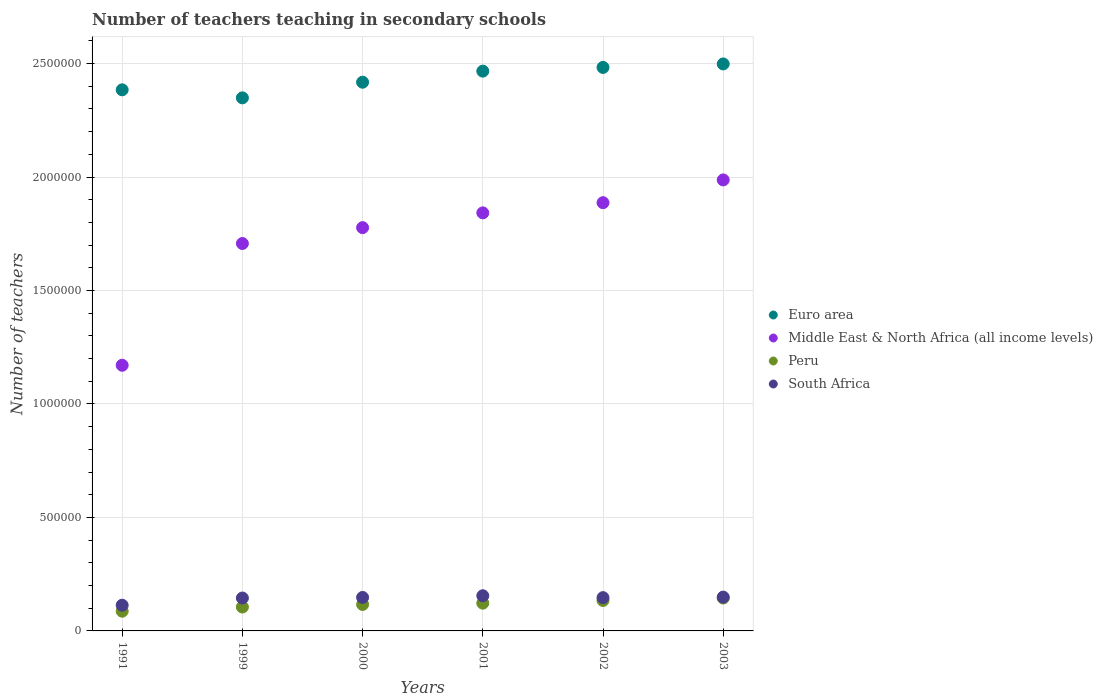How many different coloured dotlines are there?
Offer a terse response. 4. Is the number of dotlines equal to the number of legend labels?
Offer a terse response. Yes. What is the number of teachers teaching in secondary schools in Euro area in 1991?
Offer a very short reply. 2.38e+06. Across all years, what is the maximum number of teachers teaching in secondary schools in Middle East & North Africa (all income levels)?
Ensure brevity in your answer.  1.99e+06. Across all years, what is the minimum number of teachers teaching in secondary schools in South Africa?
Make the answer very short. 1.13e+05. In which year was the number of teachers teaching in secondary schools in Peru minimum?
Your response must be concise. 1991. What is the total number of teachers teaching in secondary schools in South Africa in the graph?
Your response must be concise. 8.56e+05. What is the difference between the number of teachers teaching in secondary schools in Euro area in 2000 and that in 2001?
Provide a short and direct response. -4.88e+04. What is the difference between the number of teachers teaching in secondary schools in Middle East & North Africa (all income levels) in 1991 and the number of teachers teaching in secondary schools in South Africa in 2003?
Provide a succinct answer. 1.02e+06. What is the average number of teachers teaching in secondary schools in Middle East & North Africa (all income levels) per year?
Your answer should be compact. 1.73e+06. In the year 1991, what is the difference between the number of teachers teaching in secondary schools in Middle East & North Africa (all income levels) and number of teachers teaching in secondary schools in Euro area?
Make the answer very short. -1.21e+06. What is the ratio of the number of teachers teaching in secondary schools in South Africa in 1999 to that in 2002?
Provide a short and direct response. 0.99. What is the difference between the highest and the second highest number of teachers teaching in secondary schools in Peru?
Your response must be concise. 1.08e+04. What is the difference between the highest and the lowest number of teachers teaching in secondary schools in Euro area?
Your response must be concise. 1.49e+05. Is the sum of the number of teachers teaching in secondary schools in Peru in 1991 and 1999 greater than the maximum number of teachers teaching in secondary schools in Euro area across all years?
Provide a short and direct response. No. Is the number of teachers teaching in secondary schools in Middle East & North Africa (all income levels) strictly greater than the number of teachers teaching in secondary schools in Peru over the years?
Your response must be concise. Yes. Is the number of teachers teaching in secondary schools in South Africa strictly less than the number of teachers teaching in secondary schools in Euro area over the years?
Provide a short and direct response. Yes. How many dotlines are there?
Give a very brief answer. 4. What is the difference between two consecutive major ticks on the Y-axis?
Your answer should be very brief. 5.00e+05. How many legend labels are there?
Give a very brief answer. 4. How are the legend labels stacked?
Keep it short and to the point. Vertical. What is the title of the graph?
Offer a terse response. Number of teachers teaching in secondary schools. What is the label or title of the Y-axis?
Your answer should be very brief. Number of teachers. What is the Number of teachers in Euro area in 1991?
Provide a short and direct response. 2.38e+06. What is the Number of teachers in Middle East & North Africa (all income levels) in 1991?
Keep it short and to the point. 1.17e+06. What is the Number of teachers in Peru in 1991?
Your answer should be very brief. 8.69e+04. What is the Number of teachers of South Africa in 1991?
Give a very brief answer. 1.13e+05. What is the Number of teachers in Euro area in 1999?
Your answer should be very brief. 2.35e+06. What is the Number of teachers in Middle East & North Africa (all income levels) in 1999?
Give a very brief answer. 1.71e+06. What is the Number of teachers in Peru in 1999?
Provide a succinct answer. 1.05e+05. What is the Number of teachers in South Africa in 1999?
Your response must be concise. 1.45e+05. What is the Number of teachers of Euro area in 2000?
Give a very brief answer. 2.42e+06. What is the Number of teachers of Middle East & North Africa (all income levels) in 2000?
Provide a short and direct response. 1.78e+06. What is the Number of teachers in Peru in 2000?
Make the answer very short. 1.17e+05. What is the Number of teachers in South Africa in 2000?
Your response must be concise. 1.48e+05. What is the Number of teachers of Euro area in 2001?
Make the answer very short. 2.47e+06. What is the Number of teachers of Middle East & North Africa (all income levels) in 2001?
Keep it short and to the point. 1.84e+06. What is the Number of teachers in Peru in 2001?
Give a very brief answer. 1.22e+05. What is the Number of teachers in South Africa in 2001?
Give a very brief answer. 1.55e+05. What is the Number of teachers in Euro area in 2002?
Provide a succinct answer. 2.48e+06. What is the Number of teachers of Middle East & North Africa (all income levels) in 2002?
Make the answer very short. 1.89e+06. What is the Number of teachers in Peru in 2002?
Your response must be concise. 1.34e+05. What is the Number of teachers of South Africa in 2002?
Offer a terse response. 1.47e+05. What is the Number of teachers in Euro area in 2003?
Offer a very short reply. 2.50e+06. What is the Number of teachers in Middle East & North Africa (all income levels) in 2003?
Offer a terse response. 1.99e+06. What is the Number of teachers in Peru in 2003?
Offer a very short reply. 1.45e+05. What is the Number of teachers in South Africa in 2003?
Offer a terse response. 1.49e+05. Across all years, what is the maximum Number of teachers of Euro area?
Provide a short and direct response. 2.50e+06. Across all years, what is the maximum Number of teachers of Middle East & North Africa (all income levels)?
Give a very brief answer. 1.99e+06. Across all years, what is the maximum Number of teachers in Peru?
Your answer should be compact. 1.45e+05. Across all years, what is the maximum Number of teachers in South Africa?
Ensure brevity in your answer.  1.55e+05. Across all years, what is the minimum Number of teachers of Euro area?
Your response must be concise. 2.35e+06. Across all years, what is the minimum Number of teachers of Middle East & North Africa (all income levels)?
Provide a succinct answer. 1.17e+06. Across all years, what is the minimum Number of teachers of Peru?
Your answer should be compact. 8.69e+04. Across all years, what is the minimum Number of teachers in South Africa?
Your answer should be compact. 1.13e+05. What is the total Number of teachers of Euro area in the graph?
Your answer should be compact. 1.46e+07. What is the total Number of teachers in Middle East & North Africa (all income levels) in the graph?
Provide a succinct answer. 1.04e+07. What is the total Number of teachers in Peru in the graph?
Your response must be concise. 7.10e+05. What is the total Number of teachers in South Africa in the graph?
Ensure brevity in your answer.  8.56e+05. What is the difference between the Number of teachers in Euro area in 1991 and that in 1999?
Provide a succinct answer. 3.54e+04. What is the difference between the Number of teachers of Middle East & North Africa (all income levels) in 1991 and that in 1999?
Your answer should be very brief. -5.36e+05. What is the difference between the Number of teachers of Peru in 1991 and that in 1999?
Your answer should be compact. -1.84e+04. What is the difference between the Number of teachers in South Africa in 1991 and that in 1999?
Your answer should be very brief. -3.17e+04. What is the difference between the Number of teachers of Euro area in 1991 and that in 2000?
Your answer should be compact. -3.36e+04. What is the difference between the Number of teachers in Middle East & North Africa (all income levels) in 1991 and that in 2000?
Your answer should be very brief. -6.06e+05. What is the difference between the Number of teachers of Peru in 1991 and that in 2000?
Make the answer very short. -2.97e+04. What is the difference between the Number of teachers in South Africa in 1991 and that in 2000?
Make the answer very short. -3.44e+04. What is the difference between the Number of teachers in Euro area in 1991 and that in 2001?
Your answer should be very brief. -8.24e+04. What is the difference between the Number of teachers of Middle East & North Africa (all income levels) in 1991 and that in 2001?
Offer a very short reply. -6.72e+05. What is the difference between the Number of teachers in Peru in 1991 and that in 2001?
Make the answer very short. -3.54e+04. What is the difference between the Number of teachers of South Africa in 1991 and that in 2001?
Offer a very short reply. -4.17e+04. What is the difference between the Number of teachers in Euro area in 1991 and that in 2002?
Provide a short and direct response. -9.87e+04. What is the difference between the Number of teachers of Middle East & North Africa (all income levels) in 1991 and that in 2002?
Offer a very short reply. -7.16e+05. What is the difference between the Number of teachers in Peru in 1991 and that in 2002?
Give a very brief answer. -4.74e+04. What is the difference between the Number of teachers in South Africa in 1991 and that in 2002?
Ensure brevity in your answer.  -3.34e+04. What is the difference between the Number of teachers of Euro area in 1991 and that in 2003?
Your answer should be very brief. -1.14e+05. What is the difference between the Number of teachers of Middle East & North Africa (all income levels) in 1991 and that in 2003?
Your answer should be very brief. -8.17e+05. What is the difference between the Number of teachers of Peru in 1991 and that in 2003?
Keep it short and to the point. -5.81e+04. What is the difference between the Number of teachers in South Africa in 1991 and that in 2003?
Offer a terse response. -3.58e+04. What is the difference between the Number of teachers in Euro area in 1999 and that in 2000?
Ensure brevity in your answer.  -6.90e+04. What is the difference between the Number of teachers of Middle East & North Africa (all income levels) in 1999 and that in 2000?
Offer a terse response. -6.99e+04. What is the difference between the Number of teachers of Peru in 1999 and that in 2000?
Provide a short and direct response. -1.13e+04. What is the difference between the Number of teachers of South Africa in 1999 and that in 2000?
Your answer should be very brief. -2663. What is the difference between the Number of teachers of Euro area in 1999 and that in 2001?
Give a very brief answer. -1.18e+05. What is the difference between the Number of teachers in Middle East & North Africa (all income levels) in 1999 and that in 2001?
Offer a very short reply. -1.35e+05. What is the difference between the Number of teachers of Peru in 1999 and that in 2001?
Your response must be concise. -1.70e+04. What is the difference between the Number of teachers in South Africa in 1999 and that in 2001?
Offer a very short reply. -1.00e+04. What is the difference between the Number of teachers in Euro area in 1999 and that in 2002?
Ensure brevity in your answer.  -1.34e+05. What is the difference between the Number of teachers in Middle East & North Africa (all income levels) in 1999 and that in 2002?
Provide a short and direct response. -1.80e+05. What is the difference between the Number of teachers in Peru in 1999 and that in 2002?
Offer a very short reply. -2.90e+04. What is the difference between the Number of teachers in South Africa in 1999 and that in 2002?
Your response must be concise. -1694. What is the difference between the Number of teachers in Euro area in 1999 and that in 2003?
Your answer should be compact. -1.49e+05. What is the difference between the Number of teachers in Middle East & North Africa (all income levels) in 1999 and that in 2003?
Your answer should be compact. -2.80e+05. What is the difference between the Number of teachers of Peru in 1999 and that in 2003?
Offer a terse response. -3.97e+04. What is the difference between the Number of teachers in South Africa in 1999 and that in 2003?
Keep it short and to the point. -4097. What is the difference between the Number of teachers in Euro area in 2000 and that in 2001?
Your answer should be very brief. -4.88e+04. What is the difference between the Number of teachers in Middle East & North Africa (all income levels) in 2000 and that in 2001?
Ensure brevity in your answer.  -6.52e+04. What is the difference between the Number of teachers in Peru in 2000 and that in 2001?
Ensure brevity in your answer.  -5685. What is the difference between the Number of teachers of South Africa in 2000 and that in 2001?
Give a very brief answer. -7348. What is the difference between the Number of teachers of Euro area in 2000 and that in 2002?
Provide a short and direct response. -6.51e+04. What is the difference between the Number of teachers of Middle East & North Africa (all income levels) in 2000 and that in 2002?
Your answer should be compact. -1.10e+05. What is the difference between the Number of teachers of Peru in 2000 and that in 2002?
Provide a succinct answer. -1.77e+04. What is the difference between the Number of teachers of South Africa in 2000 and that in 2002?
Your answer should be compact. 969. What is the difference between the Number of teachers of Euro area in 2000 and that in 2003?
Ensure brevity in your answer.  -8.05e+04. What is the difference between the Number of teachers in Middle East & North Africa (all income levels) in 2000 and that in 2003?
Your answer should be very brief. -2.10e+05. What is the difference between the Number of teachers in Peru in 2000 and that in 2003?
Make the answer very short. -2.84e+04. What is the difference between the Number of teachers in South Africa in 2000 and that in 2003?
Offer a very short reply. -1434. What is the difference between the Number of teachers in Euro area in 2001 and that in 2002?
Give a very brief answer. -1.64e+04. What is the difference between the Number of teachers in Middle East & North Africa (all income levels) in 2001 and that in 2002?
Provide a succinct answer. -4.48e+04. What is the difference between the Number of teachers in Peru in 2001 and that in 2002?
Offer a very short reply. -1.20e+04. What is the difference between the Number of teachers in South Africa in 2001 and that in 2002?
Your answer should be very brief. 8317. What is the difference between the Number of teachers of Euro area in 2001 and that in 2003?
Make the answer very short. -3.17e+04. What is the difference between the Number of teachers in Middle East & North Africa (all income levels) in 2001 and that in 2003?
Give a very brief answer. -1.45e+05. What is the difference between the Number of teachers in Peru in 2001 and that in 2003?
Your answer should be compact. -2.27e+04. What is the difference between the Number of teachers of South Africa in 2001 and that in 2003?
Your answer should be compact. 5914. What is the difference between the Number of teachers in Euro area in 2002 and that in 2003?
Offer a very short reply. -1.54e+04. What is the difference between the Number of teachers of Middle East & North Africa (all income levels) in 2002 and that in 2003?
Make the answer very short. -1.00e+05. What is the difference between the Number of teachers of Peru in 2002 and that in 2003?
Your answer should be compact. -1.08e+04. What is the difference between the Number of teachers of South Africa in 2002 and that in 2003?
Ensure brevity in your answer.  -2403. What is the difference between the Number of teachers in Euro area in 1991 and the Number of teachers in Middle East & North Africa (all income levels) in 1999?
Ensure brevity in your answer.  6.77e+05. What is the difference between the Number of teachers of Euro area in 1991 and the Number of teachers of Peru in 1999?
Offer a very short reply. 2.28e+06. What is the difference between the Number of teachers in Euro area in 1991 and the Number of teachers in South Africa in 1999?
Your response must be concise. 2.24e+06. What is the difference between the Number of teachers in Middle East & North Africa (all income levels) in 1991 and the Number of teachers in Peru in 1999?
Provide a short and direct response. 1.07e+06. What is the difference between the Number of teachers in Middle East & North Africa (all income levels) in 1991 and the Number of teachers in South Africa in 1999?
Provide a short and direct response. 1.03e+06. What is the difference between the Number of teachers in Peru in 1991 and the Number of teachers in South Africa in 1999?
Offer a very short reply. -5.80e+04. What is the difference between the Number of teachers of Euro area in 1991 and the Number of teachers of Middle East & North Africa (all income levels) in 2000?
Make the answer very short. 6.07e+05. What is the difference between the Number of teachers of Euro area in 1991 and the Number of teachers of Peru in 2000?
Offer a very short reply. 2.27e+06. What is the difference between the Number of teachers of Euro area in 1991 and the Number of teachers of South Africa in 2000?
Make the answer very short. 2.24e+06. What is the difference between the Number of teachers in Middle East & North Africa (all income levels) in 1991 and the Number of teachers in Peru in 2000?
Keep it short and to the point. 1.05e+06. What is the difference between the Number of teachers of Middle East & North Africa (all income levels) in 1991 and the Number of teachers of South Africa in 2000?
Ensure brevity in your answer.  1.02e+06. What is the difference between the Number of teachers in Peru in 1991 and the Number of teachers in South Africa in 2000?
Ensure brevity in your answer.  -6.07e+04. What is the difference between the Number of teachers in Euro area in 1991 and the Number of teachers in Middle East & North Africa (all income levels) in 2001?
Provide a short and direct response. 5.42e+05. What is the difference between the Number of teachers in Euro area in 1991 and the Number of teachers in Peru in 2001?
Your response must be concise. 2.26e+06. What is the difference between the Number of teachers in Euro area in 1991 and the Number of teachers in South Africa in 2001?
Make the answer very short. 2.23e+06. What is the difference between the Number of teachers of Middle East & North Africa (all income levels) in 1991 and the Number of teachers of Peru in 2001?
Offer a very short reply. 1.05e+06. What is the difference between the Number of teachers in Middle East & North Africa (all income levels) in 1991 and the Number of teachers in South Africa in 2001?
Offer a very short reply. 1.02e+06. What is the difference between the Number of teachers in Peru in 1991 and the Number of teachers in South Africa in 2001?
Provide a succinct answer. -6.80e+04. What is the difference between the Number of teachers in Euro area in 1991 and the Number of teachers in Middle East & North Africa (all income levels) in 2002?
Keep it short and to the point. 4.97e+05. What is the difference between the Number of teachers of Euro area in 1991 and the Number of teachers of Peru in 2002?
Your response must be concise. 2.25e+06. What is the difference between the Number of teachers of Euro area in 1991 and the Number of teachers of South Africa in 2002?
Keep it short and to the point. 2.24e+06. What is the difference between the Number of teachers of Middle East & North Africa (all income levels) in 1991 and the Number of teachers of Peru in 2002?
Your answer should be compact. 1.04e+06. What is the difference between the Number of teachers of Middle East & North Africa (all income levels) in 1991 and the Number of teachers of South Africa in 2002?
Offer a very short reply. 1.02e+06. What is the difference between the Number of teachers of Peru in 1991 and the Number of teachers of South Africa in 2002?
Ensure brevity in your answer.  -5.97e+04. What is the difference between the Number of teachers in Euro area in 1991 and the Number of teachers in Middle East & North Africa (all income levels) in 2003?
Offer a very short reply. 3.97e+05. What is the difference between the Number of teachers of Euro area in 1991 and the Number of teachers of Peru in 2003?
Offer a very short reply. 2.24e+06. What is the difference between the Number of teachers of Euro area in 1991 and the Number of teachers of South Africa in 2003?
Provide a succinct answer. 2.24e+06. What is the difference between the Number of teachers of Middle East & North Africa (all income levels) in 1991 and the Number of teachers of Peru in 2003?
Your response must be concise. 1.03e+06. What is the difference between the Number of teachers of Middle East & North Africa (all income levels) in 1991 and the Number of teachers of South Africa in 2003?
Provide a succinct answer. 1.02e+06. What is the difference between the Number of teachers of Peru in 1991 and the Number of teachers of South Africa in 2003?
Keep it short and to the point. -6.21e+04. What is the difference between the Number of teachers of Euro area in 1999 and the Number of teachers of Middle East & North Africa (all income levels) in 2000?
Offer a terse response. 5.72e+05. What is the difference between the Number of teachers of Euro area in 1999 and the Number of teachers of Peru in 2000?
Keep it short and to the point. 2.23e+06. What is the difference between the Number of teachers in Euro area in 1999 and the Number of teachers in South Africa in 2000?
Offer a terse response. 2.20e+06. What is the difference between the Number of teachers of Middle East & North Africa (all income levels) in 1999 and the Number of teachers of Peru in 2000?
Keep it short and to the point. 1.59e+06. What is the difference between the Number of teachers in Middle East & North Africa (all income levels) in 1999 and the Number of teachers in South Africa in 2000?
Keep it short and to the point. 1.56e+06. What is the difference between the Number of teachers of Peru in 1999 and the Number of teachers of South Africa in 2000?
Ensure brevity in your answer.  -4.23e+04. What is the difference between the Number of teachers of Euro area in 1999 and the Number of teachers of Middle East & North Africa (all income levels) in 2001?
Your answer should be very brief. 5.07e+05. What is the difference between the Number of teachers in Euro area in 1999 and the Number of teachers in Peru in 2001?
Offer a terse response. 2.23e+06. What is the difference between the Number of teachers of Euro area in 1999 and the Number of teachers of South Africa in 2001?
Offer a very short reply. 2.19e+06. What is the difference between the Number of teachers of Middle East & North Africa (all income levels) in 1999 and the Number of teachers of Peru in 2001?
Offer a terse response. 1.58e+06. What is the difference between the Number of teachers in Middle East & North Africa (all income levels) in 1999 and the Number of teachers in South Africa in 2001?
Your response must be concise. 1.55e+06. What is the difference between the Number of teachers of Peru in 1999 and the Number of teachers of South Africa in 2001?
Ensure brevity in your answer.  -4.96e+04. What is the difference between the Number of teachers in Euro area in 1999 and the Number of teachers in Middle East & North Africa (all income levels) in 2002?
Your answer should be very brief. 4.62e+05. What is the difference between the Number of teachers in Euro area in 1999 and the Number of teachers in Peru in 2002?
Ensure brevity in your answer.  2.21e+06. What is the difference between the Number of teachers of Euro area in 1999 and the Number of teachers of South Africa in 2002?
Ensure brevity in your answer.  2.20e+06. What is the difference between the Number of teachers of Middle East & North Africa (all income levels) in 1999 and the Number of teachers of Peru in 2002?
Your answer should be very brief. 1.57e+06. What is the difference between the Number of teachers of Middle East & North Africa (all income levels) in 1999 and the Number of teachers of South Africa in 2002?
Offer a very short reply. 1.56e+06. What is the difference between the Number of teachers of Peru in 1999 and the Number of teachers of South Africa in 2002?
Your answer should be compact. -4.13e+04. What is the difference between the Number of teachers in Euro area in 1999 and the Number of teachers in Middle East & North Africa (all income levels) in 2003?
Provide a succinct answer. 3.62e+05. What is the difference between the Number of teachers of Euro area in 1999 and the Number of teachers of Peru in 2003?
Your response must be concise. 2.20e+06. What is the difference between the Number of teachers of Euro area in 1999 and the Number of teachers of South Africa in 2003?
Your answer should be very brief. 2.20e+06. What is the difference between the Number of teachers of Middle East & North Africa (all income levels) in 1999 and the Number of teachers of Peru in 2003?
Offer a terse response. 1.56e+06. What is the difference between the Number of teachers in Middle East & North Africa (all income levels) in 1999 and the Number of teachers in South Africa in 2003?
Provide a succinct answer. 1.56e+06. What is the difference between the Number of teachers in Peru in 1999 and the Number of teachers in South Africa in 2003?
Provide a succinct answer. -4.37e+04. What is the difference between the Number of teachers in Euro area in 2000 and the Number of teachers in Middle East & North Africa (all income levels) in 2001?
Provide a short and direct response. 5.76e+05. What is the difference between the Number of teachers in Euro area in 2000 and the Number of teachers in Peru in 2001?
Offer a very short reply. 2.30e+06. What is the difference between the Number of teachers in Euro area in 2000 and the Number of teachers in South Africa in 2001?
Your answer should be compact. 2.26e+06. What is the difference between the Number of teachers in Middle East & North Africa (all income levels) in 2000 and the Number of teachers in Peru in 2001?
Ensure brevity in your answer.  1.65e+06. What is the difference between the Number of teachers of Middle East & North Africa (all income levels) in 2000 and the Number of teachers of South Africa in 2001?
Offer a very short reply. 1.62e+06. What is the difference between the Number of teachers in Peru in 2000 and the Number of teachers in South Africa in 2001?
Ensure brevity in your answer.  -3.83e+04. What is the difference between the Number of teachers of Euro area in 2000 and the Number of teachers of Middle East & North Africa (all income levels) in 2002?
Offer a very short reply. 5.31e+05. What is the difference between the Number of teachers in Euro area in 2000 and the Number of teachers in Peru in 2002?
Provide a succinct answer. 2.28e+06. What is the difference between the Number of teachers in Euro area in 2000 and the Number of teachers in South Africa in 2002?
Offer a terse response. 2.27e+06. What is the difference between the Number of teachers in Middle East & North Africa (all income levels) in 2000 and the Number of teachers in Peru in 2002?
Provide a succinct answer. 1.64e+06. What is the difference between the Number of teachers in Middle East & North Africa (all income levels) in 2000 and the Number of teachers in South Africa in 2002?
Your answer should be very brief. 1.63e+06. What is the difference between the Number of teachers of Peru in 2000 and the Number of teachers of South Africa in 2002?
Ensure brevity in your answer.  -3.00e+04. What is the difference between the Number of teachers in Euro area in 2000 and the Number of teachers in Middle East & North Africa (all income levels) in 2003?
Offer a very short reply. 4.31e+05. What is the difference between the Number of teachers of Euro area in 2000 and the Number of teachers of Peru in 2003?
Offer a very short reply. 2.27e+06. What is the difference between the Number of teachers in Euro area in 2000 and the Number of teachers in South Africa in 2003?
Ensure brevity in your answer.  2.27e+06. What is the difference between the Number of teachers in Middle East & North Africa (all income levels) in 2000 and the Number of teachers in Peru in 2003?
Provide a short and direct response. 1.63e+06. What is the difference between the Number of teachers in Middle East & North Africa (all income levels) in 2000 and the Number of teachers in South Africa in 2003?
Your answer should be compact. 1.63e+06. What is the difference between the Number of teachers in Peru in 2000 and the Number of teachers in South Africa in 2003?
Offer a very short reply. -3.24e+04. What is the difference between the Number of teachers of Euro area in 2001 and the Number of teachers of Middle East & North Africa (all income levels) in 2002?
Offer a very short reply. 5.80e+05. What is the difference between the Number of teachers of Euro area in 2001 and the Number of teachers of Peru in 2002?
Offer a very short reply. 2.33e+06. What is the difference between the Number of teachers in Euro area in 2001 and the Number of teachers in South Africa in 2002?
Provide a short and direct response. 2.32e+06. What is the difference between the Number of teachers in Middle East & North Africa (all income levels) in 2001 and the Number of teachers in Peru in 2002?
Provide a succinct answer. 1.71e+06. What is the difference between the Number of teachers in Middle East & North Africa (all income levels) in 2001 and the Number of teachers in South Africa in 2002?
Ensure brevity in your answer.  1.70e+06. What is the difference between the Number of teachers of Peru in 2001 and the Number of teachers of South Africa in 2002?
Ensure brevity in your answer.  -2.43e+04. What is the difference between the Number of teachers in Euro area in 2001 and the Number of teachers in Middle East & North Africa (all income levels) in 2003?
Keep it short and to the point. 4.79e+05. What is the difference between the Number of teachers of Euro area in 2001 and the Number of teachers of Peru in 2003?
Your answer should be very brief. 2.32e+06. What is the difference between the Number of teachers of Euro area in 2001 and the Number of teachers of South Africa in 2003?
Provide a succinct answer. 2.32e+06. What is the difference between the Number of teachers in Middle East & North Africa (all income levels) in 2001 and the Number of teachers in Peru in 2003?
Your response must be concise. 1.70e+06. What is the difference between the Number of teachers of Middle East & North Africa (all income levels) in 2001 and the Number of teachers of South Africa in 2003?
Ensure brevity in your answer.  1.69e+06. What is the difference between the Number of teachers of Peru in 2001 and the Number of teachers of South Africa in 2003?
Offer a very short reply. -2.67e+04. What is the difference between the Number of teachers in Euro area in 2002 and the Number of teachers in Middle East & North Africa (all income levels) in 2003?
Offer a terse response. 4.96e+05. What is the difference between the Number of teachers in Euro area in 2002 and the Number of teachers in Peru in 2003?
Your answer should be compact. 2.34e+06. What is the difference between the Number of teachers of Euro area in 2002 and the Number of teachers of South Africa in 2003?
Offer a terse response. 2.33e+06. What is the difference between the Number of teachers of Middle East & North Africa (all income levels) in 2002 and the Number of teachers of Peru in 2003?
Provide a succinct answer. 1.74e+06. What is the difference between the Number of teachers in Middle East & North Africa (all income levels) in 2002 and the Number of teachers in South Africa in 2003?
Ensure brevity in your answer.  1.74e+06. What is the difference between the Number of teachers of Peru in 2002 and the Number of teachers of South Africa in 2003?
Your answer should be compact. -1.48e+04. What is the average Number of teachers in Euro area per year?
Your answer should be compact. 2.43e+06. What is the average Number of teachers of Middle East & North Africa (all income levels) per year?
Your answer should be compact. 1.73e+06. What is the average Number of teachers in Peru per year?
Make the answer very short. 1.18e+05. What is the average Number of teachers of South Africa per year?
Keep it short and to the point. 1.43e+05. In the year 1991, what is the difference between the Number of teachers of Euro area and Number of teachers of Middle East & North Africa (all income levels)?
Provide a succinct answer. 1.21e+06. In the year 1991, what is the difference between the Number of teachers in Euro area and Number of teachers in Peru?
Ensure brevity in your answer.  2.30e+06. In the year 1991, what is the difference between the Number of teachers of Euro area and Number of teachers of South Africa?
Provide a succinct answer. 2.27e+06. In the year 1991, what is the difference between the Number of teachers of Middle East & North Africa (all income levels) and Number of teachers of Peru?
Your answer should be very brief. 1.08e+06. In the year 1991, what is the difference between the Number of teachers of Middle East & North Africa (all income levels) and Number of teachers of South Africa?
Your answer should be compact. 1.06e+06. In the year 1991, what is the difference between the Number of teachers in Peru and Number of teachers in South Africa?
Your response must be concise. -2.63e+04. In the year 1999, what is the difference between the Number of teachers in Euro area and Number of teachers in Middle East & North Africa (all income levels)?
Your response must be concise. 6.42e+05. In the year 1999, what is the difference between the Number of teachers of Euro area and Number of teachers of Peru?
Provide a succinct answer. 2.24e+06. In the year 1999, what is the difference between the Number of teachers in Euro area and Number of teachers in South Africa?
Give a very brief answer. 2.20e+06. In the year 1999, what is the difference between the Number of teachers in Middle East & North Africa (all income levels) and Number of teachers in Peru?
Ensure brevity in your answer.  1.60e+06. In the year 1999, what is the difference between the Number of teachers of Middle East & North Africa (all income levels) and Number of teachers of South Africa?
Your answer should be very brief. 1.56e+06. In the year 1999, what is the difference between the Number of teachers in Peru and Number of teachers in South Africa?
Make the answer very short. -3.96e+04. In the year 2000, what is the difference between the Number of teachers in Euro area and Number of teachers in Middle East & North Africa (all income levels)?
Keep it short and to the point. 6.41e+05. In the year 2000, what is the difference between the Number of teachers in Euro area and Number of teachers in Peru?
Give a very brief answer. 2.30e+06. In the year 2000, what is the difference between the Number of teachers in Euro area and Number of teachers in South Africa?
Offer a very short reply. 2.27e+06. In the year 2000, what is the difference between the Number of teachers in Middle East & North Africa (all income levels) and Number of teachers in Peru?
Your answer should be very brief. 1.66e+06. In the year 2000, what is the difference between the Number of teachers in Middle East & North Africa (all income levels) and Number of teachers in South Africa?
Your answer should be very brief. 1.63e+06. In the year 2000, what is the difference between the Number of teachers in Peru and Number of teachers in South Africa?
Keep it short and to the point. -3.10e+04. In the year 2001, what is the difference between the Number of teachers in Euro area and Number of teachers in Middle East & North Africa (all income levels)?
Give a very brief answer. 6.25e+05. In the year 2001, what is the difference between the Number of teachers of Euro area and Number of teachers of Peru?
Provide a succinct answer. 2.34e+06. In the year 2001, what is the difference between the Number of teachers in Euro area and Number of teachers in South Africa?
Offer a very short reply. 2.31e+06. In the year 2001, what is the difference between the Number of teachers of Middle East & North Africa (all income levels) and Number of teachers of Peru?
Ensure brevity in your answer.  1.72e+06. In the year 2001, what is the difference between the Number of teachers in Middle East & North Africa (all income levels) and Number of teachers in South Africa?
Keep it short and to the point. 1.69e+06. In the year 2001, what is the difference between the Number of teachers of Peru and Number of teachers of South Africa?
Your answer should be compact. -3.27e+04. In the year 2002, what is the difference between the Number of teachers of Euro area and Number of teachers of Middle East & North Africa (all income levels)?
Provide a short and direct response. 5.96e+05. In the year 2002, what is the difference between the Number of teachers in Euro area and Number of teachers in Peru?
Give a very brief answer. 2.35e+06. In the year 2002, what is the difference between the Number of teachers of Euro area and Number of teachers of South Africa?
Keep it short and to the point. 2.34e+06. In the year 2002, what is the difference between the Number of teachers of Middle East & North Africa (all income levels) and Number of teachers of Peru?
Make the answer very short. 1.75e+06. In the year 2002, what is the difference between the Number of teachers in Middle East & North Africa (all income levels) and Number of teachers in South Africa?
Make the answer very short. 1.74e+06. In the year 2002, what is the difference between the Number of teachers in Peru and Number of teachers in South Africa?
Give a very brief answer. -1.24e+04. In the year 2003, what is the difference between the Number of teachers in Euro area and Number of teachers in Middle East & North Africa (all income levels)?
Make the answer very short. 5.11e+05. In the year 2003, what is the difference between the Number of teachers of Euro area and Number of teachers of Peru?
Your answer should be compact. 2.35e+06. In the year 2003, what is the difference between the Number of teachers of Euro area and Number of teachers of South Africa?
Ensure brevity in your answer.  2.35e+06. In the year 2003, what is the difference between the Number of teachers in Middle East & North Africa (all income levels) and Number of teachers in Peru?
Ensure brevity in your answer.  1.84e+06. In the year 2003, what is the difference between the Number of teachers in Middle East & North Africa (all income levels) and Number of teachers in South Africa?
Your response must be concise. 1.84e+06. In the year 2003, what is the difference between the Number of teachers in Peru and Number of teachers in South Africa?
Keep it short and to the point. -4014. What is the ratio of the Number of teachers of Euro area in 1991 to that in 1999?
Make the answer very short. 1.02. What is the ratio of the Number of teachers in Middle East & North Africa (all income levels) in 1991 to that in 1999?
Ensure brevity in your answer.  0.69. What is the ratio of the Number of teachers in Peru in 1991 to that in 1999?
Offer a very short reply. 0.83. What is the ratio of the Number of teachers in South Africa in 1991 to that in 1999?
Your answer should be compact. 0.78. What is the ratio of the Number of teachers in Euro area in 1991 to that in 2000?
Your response must be concise. 0.99. What is the ratio of the Number of teachers of Middle East & North Africa (all income levels) in 1991 to that in 2000?
Ensure brevity in your answer.  0.66. What is the ratio of the Number of teachers in Peru in 1991 to that in 2000?
Your answer should be compact. 0.75. What is the ratio of the Number of teachers in South Africa in 1991 to that in 2000?
Keep it short and to the point. 0.77. What is the ratio of the Number of teachers of Euro area in 1991 to that in 2001?
Provide a short and direct response. 0.97. What is the ratio of the Number of teachers of Middle East & North Africa (all income levels) in 1991 to that in 2001?
Keep it short and to the point. 0.64. What is the ratio of the Number of teachers in Peru in 1991 to that in 2001?
Provide a short and direct response. 0.71. What is the ratio of the Number of teachers of South Africa in 1991 to that in 2001?
Your answer should be very brief. 0.73. What is the ratio of the Number of teachers in Euro area in 1991 to that in 2002?
Offer a very short reply. 0.96. What is the ratio of the Number of teachers of Middle East & North Africa (all income levels) in 1991 to that in 2002?
Give a very brief answer. 0.62. What is the ratio of the Number of teachers of Peru in 1991 to that in 2002?
Provide a short and direct response. 0.65. What is the ratio of the Number of teachers in South Africa in 1991 to that in 2002?
Provide a short and direct response. 0.77. What is the ratio of the Number of teachers of Euro area in 1991 to that in 2003?
Provide a short and direct response. 0.95. What is the ratio of the Number of teachers in Middle East & North Africa (all income levels) in 1991 to that in 2003?
Offer a terse response. 0.59. What is the ratio of the Number of teachers in Peru in 1991 to that in 2003?
Offer a very short reply. 0.6. What is the ratio of the Number of teachers of South Africa in 1991 to that in 2003?
Provide a short and direct response. 0.76. What is the ratio of the Number of teachers of Euro area in 1999 to that in 2000?
Give a very brief answer. 0.97. What is the ratio of the Number of teachers of Middle East & North Africa (all income levels) in 1999 to that in 2000?
Offer a terse response. 0.96. What is the ratio of the Number of teachers of Peru in 1999 to that in 2000?
Provide a short and direct response. 0.9. What is the ratio of the Number of teachers of Euro area in 1999 to that in 2001?
Provide a short and direct response. 0.95. What is the ratio of the Number of teachers of Middle East & North Africa (all income levels) in 1999 to that in 2001?
Your response must be concise. 0.93. What is the ratio of the Number of teachers of Peru in 1999 to that in 2001?
Ensure brevity in your answer.  0.86. What is the ratio of the Number of teachers in South Africa in 1999 to that in 2001?
Make the answer very short. 0.94. What is the ratio of the Number of teachers of Euro area in 1999 to that in 2002?
Provide a succinct answer. 0.95. What is the ratio of the Number of teachers in Middle East & North Africa (all income levels) in 1999 to that in 2002?
Your answer should be very brief. 0.9. What is the ratio of the Number of teachers of Peru in 1999 to that in 2002?
Give a very brief answer. 0.78. What is the ratio of the Number of teachers of South Africa in 1999 to that in 2002?
Offer a very short reply. 0.99. What is the ratio of the Number of teachers of Euro area in 1999 to that in 2003?
Keep it short and to the point. 0.94. What is the ratio of the Number of teachers in Middle East & North Africa (all income levels) in 1999 to that in 2003?
Provide a short and direct response. 0.86. What is the ratio of the Number of teachers in Peru in 1999 to that in 2003?
Offer a very short reply. 0.73. What is the ratio of the Number of teachers in South Africa in 1999 to that in 2003?
Provide a succinct answer. 0.97. What is the ratio of the Number of teachers of Euro area in 2000 to that in 2001?
Your answer should be very brief. 0.98. What is the ratio of the Number of teachers in Middle East & North Africa (all income levels) in 2000 to that in 2001?
Provide a short and direct response. 0.96. What is the ratio of the Number of teachers in Peru in 2000 to that in 2001?
Give a very brief answer. 0.95. What is the ratio of the Number of teachers of South Africa in 2000 to that in 2001?
Provide a short and direct response. 0.95. What is the ratio of the Number of teachers in Euro area in 2000 to that in 2002?
Ensure brevity in your answer.  0.97. What is the ratio of the Number of teachers in Middle East & North Africa (all income levels) in 2000 to that in 2002?
Make the answer very short. 0.94. What is the ratio of the Number of teachers in Peru in 2000 to that in 2002?
Your answer should be very brief. 0.87. What is the ratio of the Number of teachers in South Africa in 2000 to that in 2002?
Provide a succinct answer. 1.01. What is the ratio of the Number of teachers in Euro area in 2000 to that in 2003?
Keep it short and to the point. 0.97. What is the ratio of the Number of teachers in Middle East & North Africa (all income levels) in 2000 to that in 2003?
Keep it short and to the point. 0.89. What is the ratio of the Number of teachers in Peru in 2000 to that in 2003?
Give a very brief answer. 0.8. What is the ratio of the Number of teachers in South Africa in 2000 to that in 2003?
Give a very brief answer. 0.99. What is the ratio of the Number of teachers in Middle East & North Africa (all income levels) in 2001 to that in 2002?
Keep it short and to the point. 0.98. What is the ratio of the Number of teachers in Peru in 2001 to that in 2002?
Provide a succinct answer. 0.91. What is the ratio of the Number of teachers in South Africa in 2001 to that in 2002?
Provide a short and direct response. 1.06. What is the ratio of the Number of teachers in Euro area in 2001 to that in 2003?
Your answer should be compact. 0.99. What is the ratio of the Number of teachers in Middle East & North Africa (all income levels) in 2001 to that in 2003?
Keep it short and to the point. 0.93. What is the ratio of the Number of teachers of Peru in 2001 to that in 2003?
Your answer should be very brief. 0.84. What is the ratio of the Number of teachers in South Africa in 2001 to that in 2003?
Your response must be concise. 1.04. What is the ratio of the Number of teachers of Middle East & North Africa (all income levels) in 2002 to that in 2003?
Make the answer very short. 0.95. What is the ratio of the Number of teachers in Peru in 2002 to that in 2003?
Offer a terse response. 0.93. What is the ratio of the Number of teachers of South Africa in 2002 to that in 2003?
Your answer should be very brief. 0.98. What is the difference between the highest and the second highest Number of teachers in Euro area?
Ensure brevity in your answer.  1.54e+04. What is the difference between the highest and the second highest Number of teachers of Middle East & North Africa (all income levels)?
Provide a short and direct response. 1.00e+05. What is the difference between the highest and the second highest Number of teachers of Peru?
Offer a terse response. 1.08e+04. What is the difference between the highest and the second highest Number of teachers of South Africa?
Give a very brief answer. 5914. What is the difference between the highest and the lowest Number of teachers of Euro area?
Your response must be concise. 1.49e+05. What is the difference between the highest and the lowest Number of teachers of Middle East & North Africa (all income levels)?
Ensure brevity in your answer.  8.17e+05. What is the difference between the highest and the lowest Number of teachers of Peru?
Ensure brevity in your answer.  5.81e+04. What is the difference between the highest and the lowest Number of teachers in South Africa?
Provide a short and direct response. 4.17e+04. 